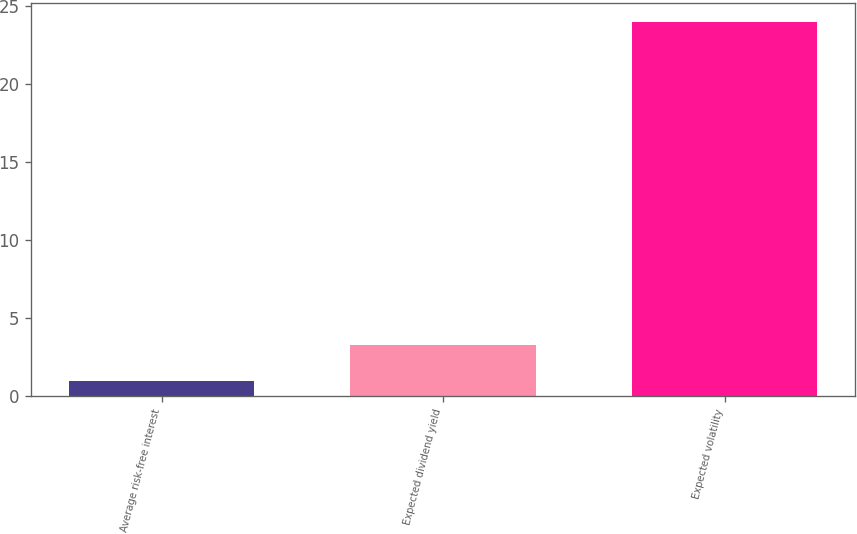<chart> <loc_0><loc_0><loc_500><loc_500><bar_chart><fcel>Average risk-free interest<fcel>Expected dividend yield<fcel>Expected volatility<nl><fcel>0.96<fcel>3.26<fcel>24<nl></chart> 